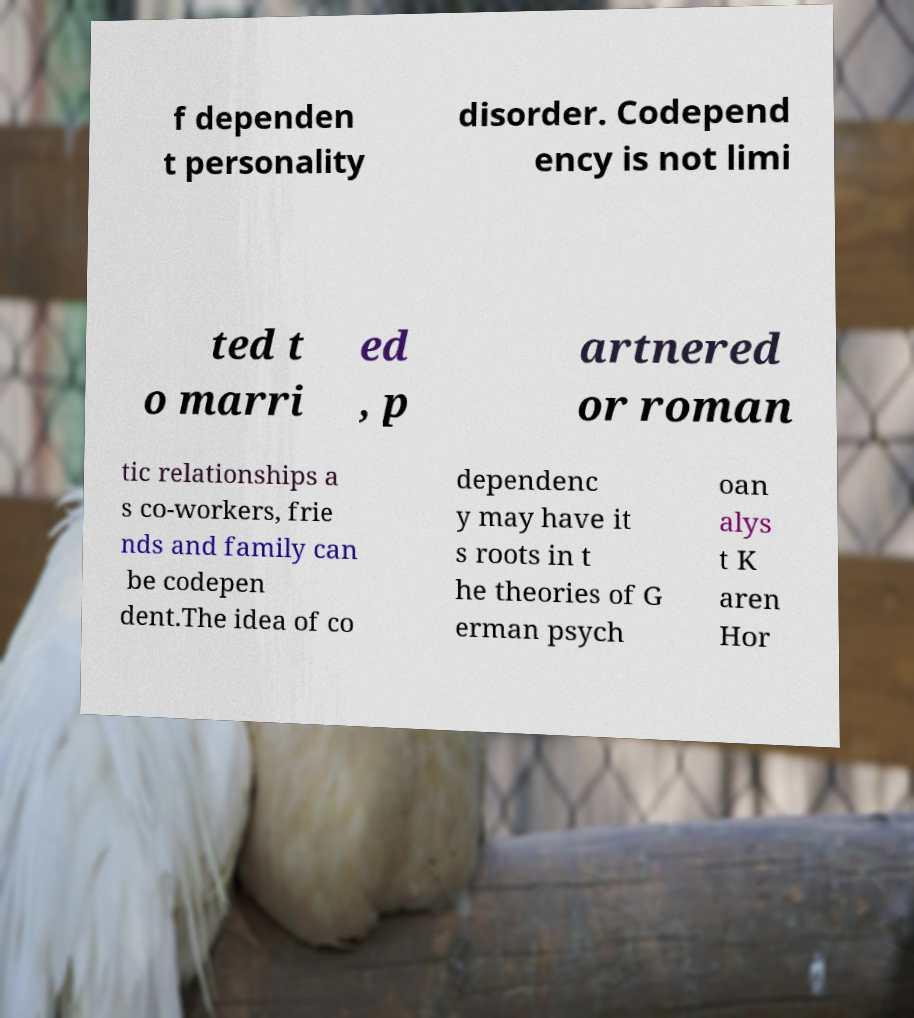Please read and relay the text visible in this image. What does it say? f dependen t personality disorder. Codepend ency is not limi ted t o marri ed , p artnered or roman tic relationships a s co-workers, frie nds and family can be codepen dent.The idea of co dependenc y may have it s roots in t he theories of G erman psych oan alys t K aren Hor 